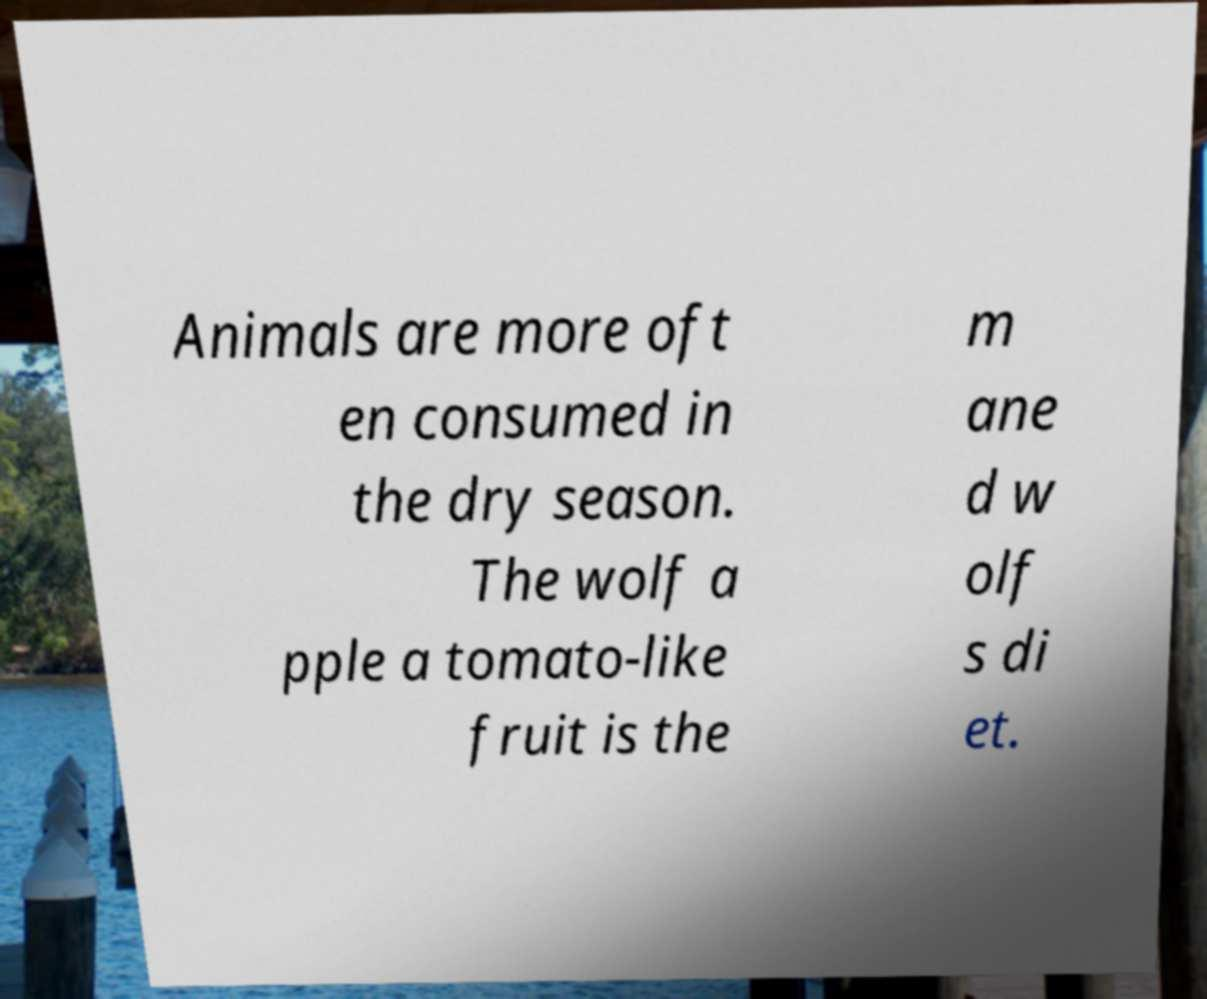Please identify and transcribe the text found in this image. Animals are more oft en consumed in the dry season. The wolf a pple a tomato-like fruit is the m ane d w olf s di et. 